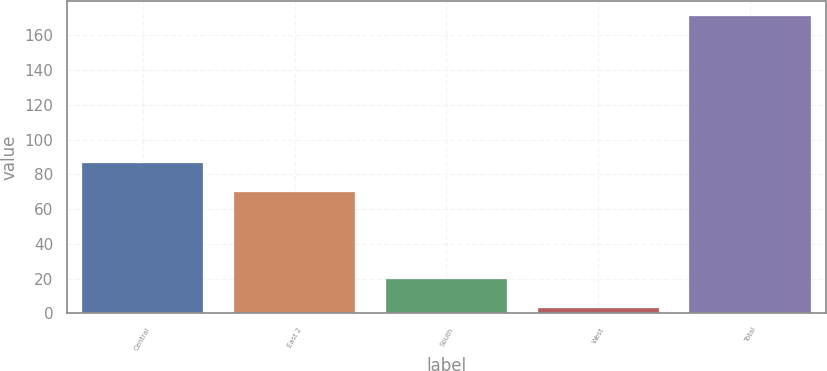Convert chart to OTSL. <chart><loc_0><loc_0><loc_500><loc_500><bar_chart><fcel>Central<fcel>East 2<fcel>South<fcel>West<fcel>Total<nl><fcel>86.8<fcel>70<fcel>19.8<fcel>3<fcel>171<nl></chart> 